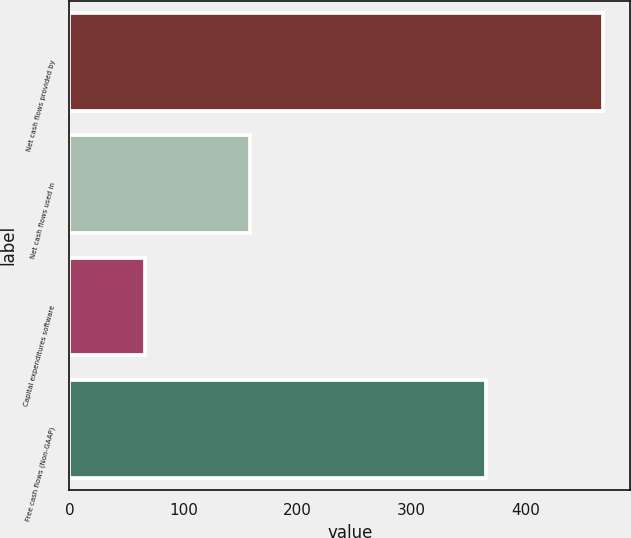Convert chart. <chart><loc_0><loc_0><loc_500><loc_500><bar_chart><fcel>Net cash flows provided by<fcel>Net cash flows used in<fcel>Capital expenditures software<fcel>Free cash flows (Non-GAAP)<nl><fcel>467.94<fcel>158.3<fcel>66<fcel>365.4<nl></chart> 